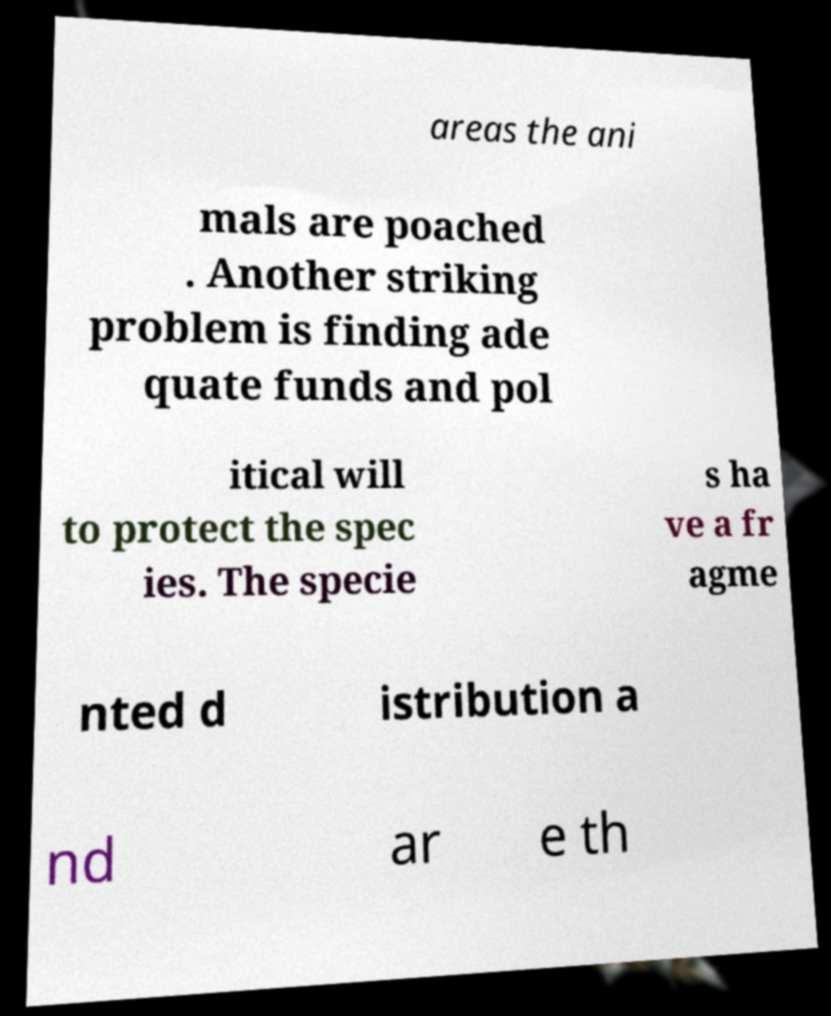Could you extract and type out the text from this image? areas the ani mals are poached . Another striking problem is finding ade quate funds and pol itical will to protect the spec ies. The specie s ha ve a fr agme nted d istribution a nd ar e th 